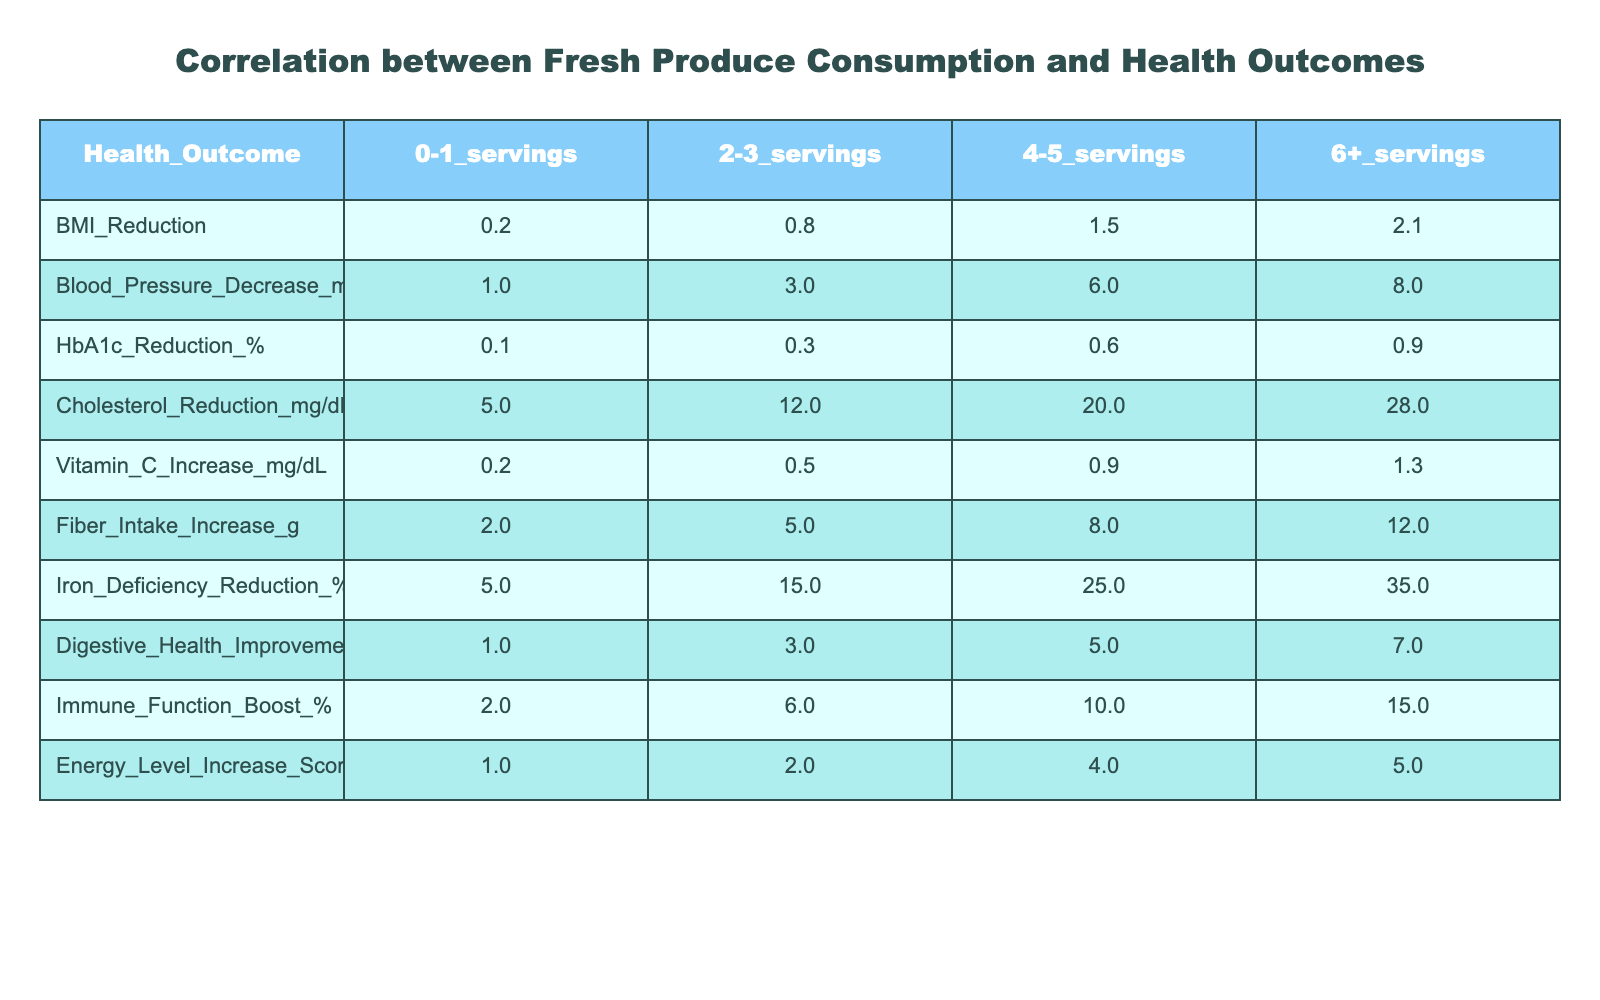What health outcome has the highest improvement with 6 or more servings of fresh produce? Looking at the table, the highest improvement for 6+ servings is in Cholesterol Reduction, which is 28 mg/dL.
Answer: Cholesterol Reduction What is the reduction in BMI when consuming 4-5 servings of fresh produce? From the table, the reduction in BMI for 4-5 servings is 1.5.
Answer: 1.5 If a family increases their fresh produce consumption from 2-3 servings to 6+ servings, what is the increase in their blood pressure decrease? The blood pressure decrease for 2-3 servings is 3 mmHg and for 6+ servings is 8 mmHg. The increase is 8 - 3 = 5 mmHg.
Answer: 5 mmHg Is the reduction in HbA1c for 0-1 servings greater than the reduction in Vitamin C increase for 2-3 servings? The reduction in HbA1c for 0-1 servings is 0.1% and the increase in Vitamin C for 2-3 servings is 0.5 mg/dL. Since 0.1% is not greater than 0.5, the answer is no.
Answer: No What is the total reduction in Iron Deficiency percentage when comparing 0-1 servings to 6+ servings? The reduction in Iron Deficiency for 0-1 servings is 5% and for 6+ servings is 35%. The total reduction is 35 - 5 = 30%.
Answer: 30% Which fresh produce intake level has the highest score for Digestive Health Improvement? The highest score in the table for Digestive Health Improvement is 7, which corresponds to the 6+ servings category.
Answer: 7 If a family decreases their fresh produce consumption from 4-5 servings to 0-1 servings, by how much would their cholesterol reduction decrease? Cholesterol reduction for 4-5 servings is 20 mg/dL and for 0-1 servings is 5 mg/dL. The decrease would be 20 - 5 = 15 mg/dL.
Answer: 15 mg/dL What is the average immune function boost across all servings of fresh produce? The immune function boost percentages are 2, 6, 10, and 15 for the respective servings. The average is (2 + 6 + 10 + 15) / 4 = 33 / 4 = 8.25%.
Answer: 8.25% Does an increase in servings of fresh produce correlate with an increase in energy levels? Observing the table, as servings increase, the energy level scores rise from 1 to 5. This indicates a positive correlation.
Answer: Yes What is the difference in energy level increase between 2-3 servings and 6+ servings? The energy level increase for 2-3 servings is 2 and for 6+ servings it is 5. The difference is 5 - 2 = 3.
Answer: 3 